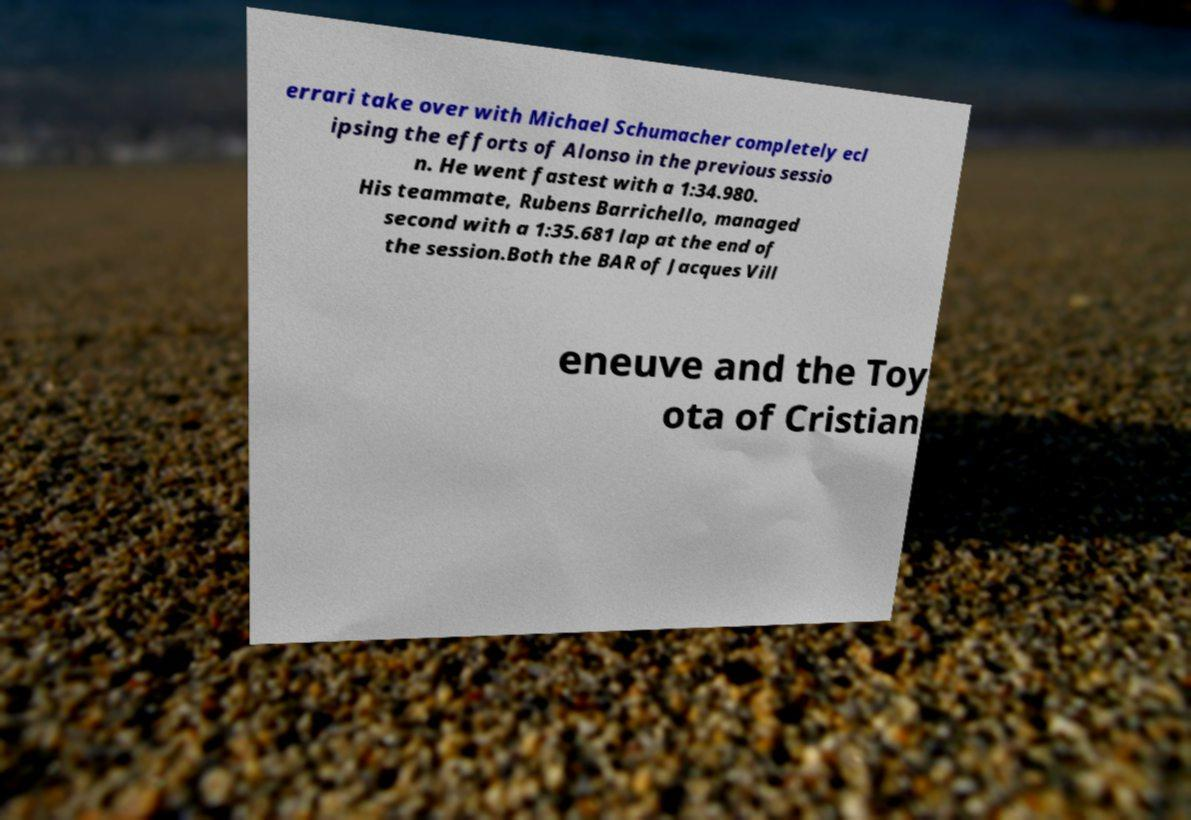For documentation purposes, I need the text within this image transcribed. Could you provide that? errari take over with Michael Schumacher completely ecl ipsing the efforts of Alonso in the previous sessio n. He went fastest with a 1:34.980. His teammate, Rubens Barrichello, managed second with a 1:35.681 lap at the end of the session.Both the BAR of Jacques Vill eneuve and the Toy ota of Cristian 